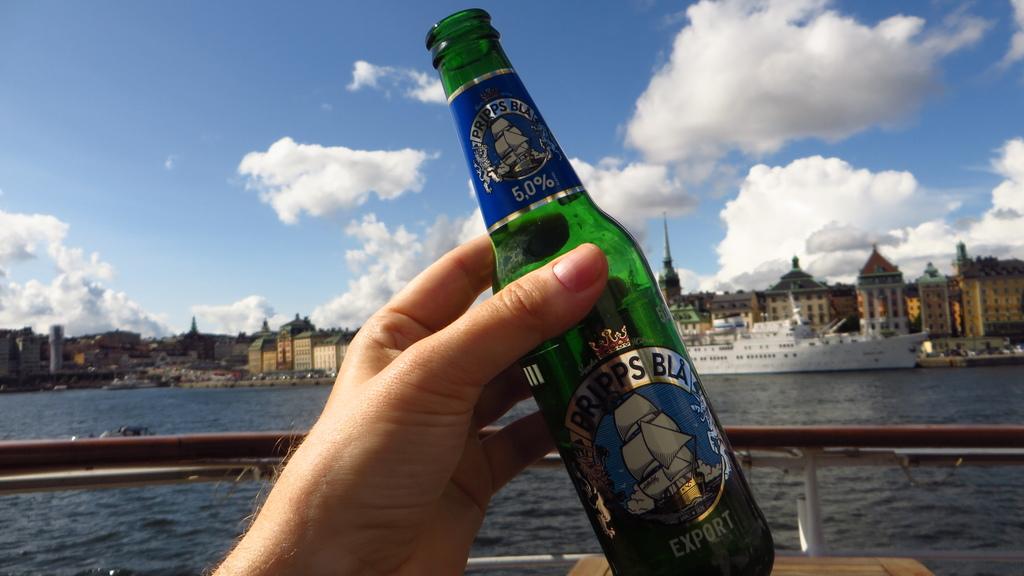What kind of beer is this?
Provide a short and direct response. Pripps bla. What color is the beer bottle?
Your response must be concise. Answering does not require reading text in the image. 